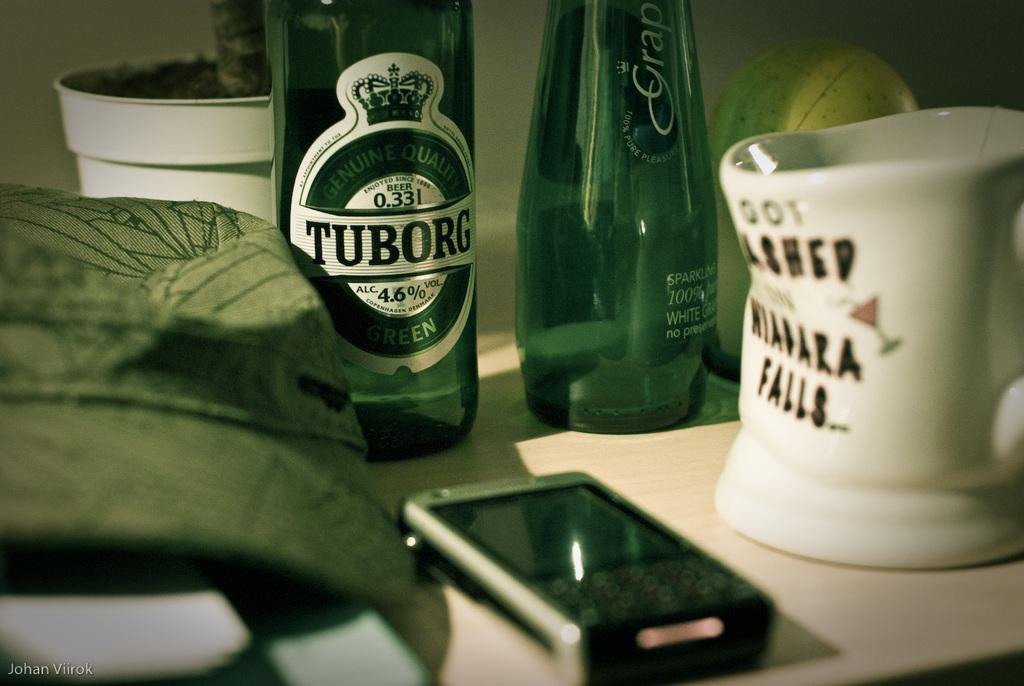<image>
Present a compact description of the photo's key features. A bottle of Tuborg is on a table with other items. 